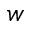Convert formula to latex. <formula><loc_0><loc_0><loc_500><loc_500>w</formula> 